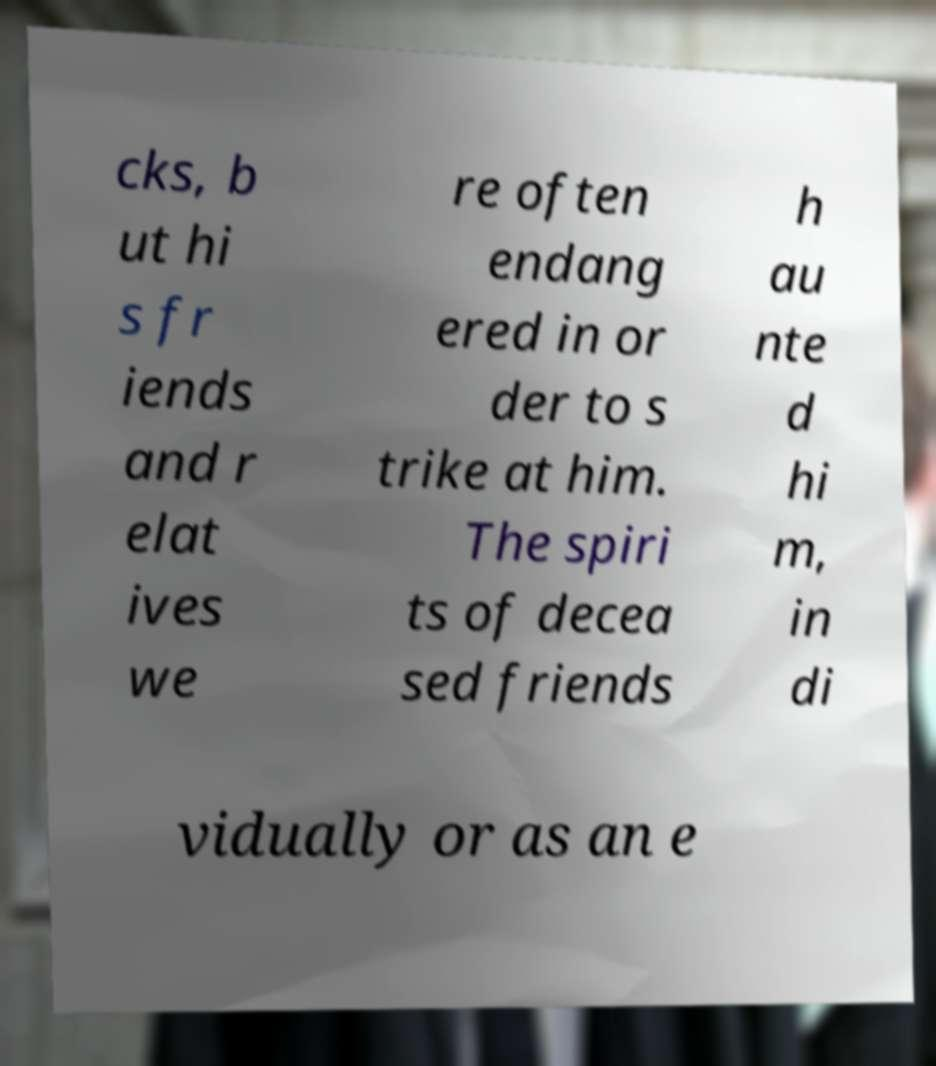I need the written content from this picture converted into text. Can you do that? cks, b ut hi s fr iends and r elat ives we re often endang ered in or der to s trike at him. The spiri ts of decea sed friends h au nte d hi m, in di vidually or as an e 